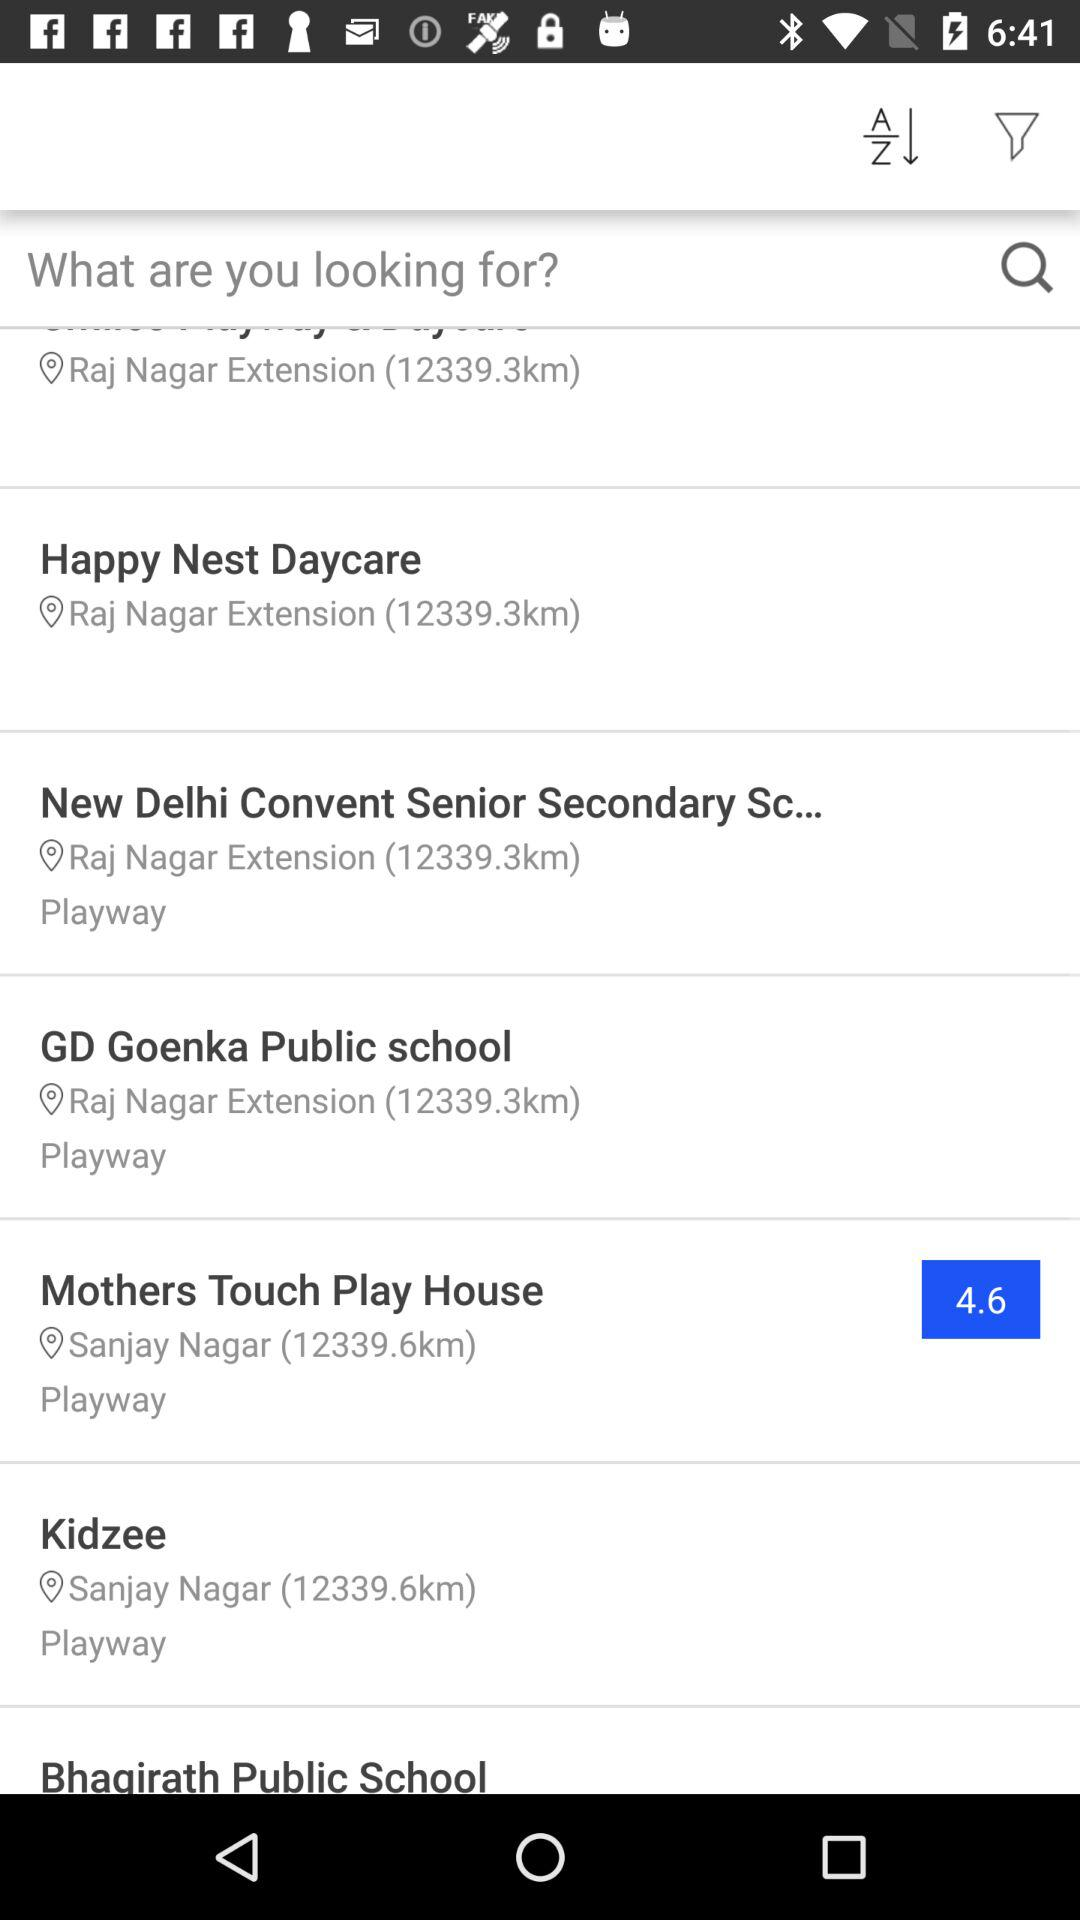What is the location of the New Delhi Convent Senior Secondary School? The location is "Raj Nagar Extension". 